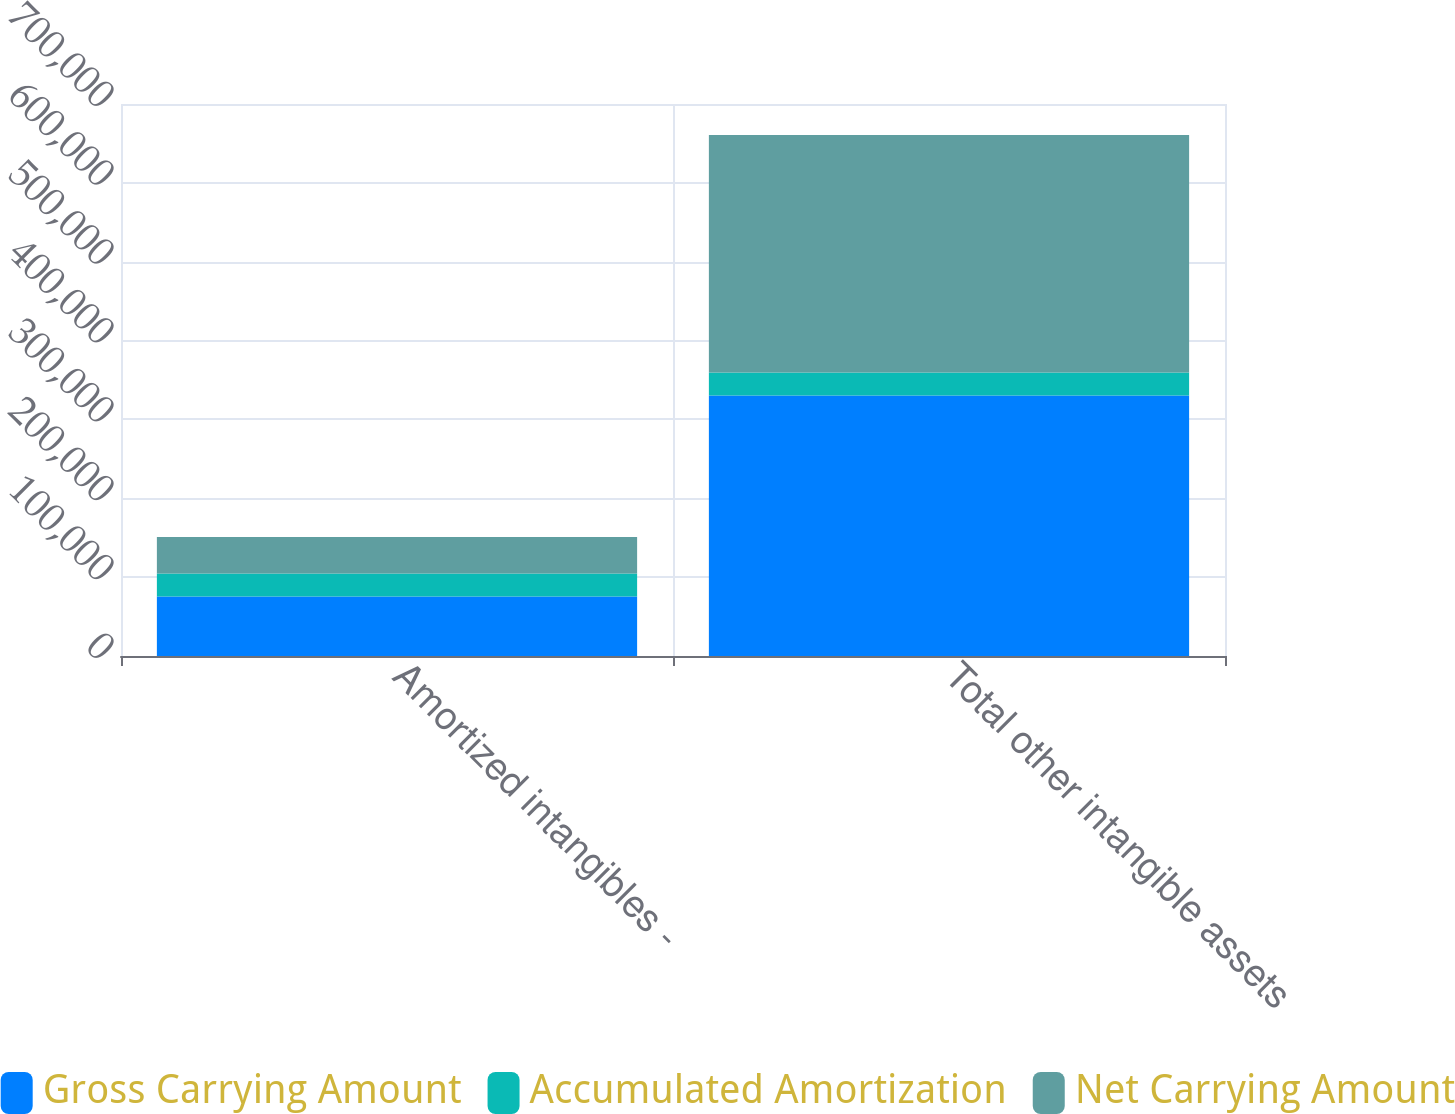<chart> <loc_0><loc_0><loc_500><loc_500><stacked_bar_chart><ecel><fcel>Amortized intangibles -<fcel>Total other intangible assets<nl><fcel>Gross Carrying Amount<fcel>75504<fcel>330286<nl><fcel>Accumulated Amortization<fcel>29188<fcel>29188<nl><fcel>Net Carrying Amount<fcel>46316<fcel>301098<nl></chart> 